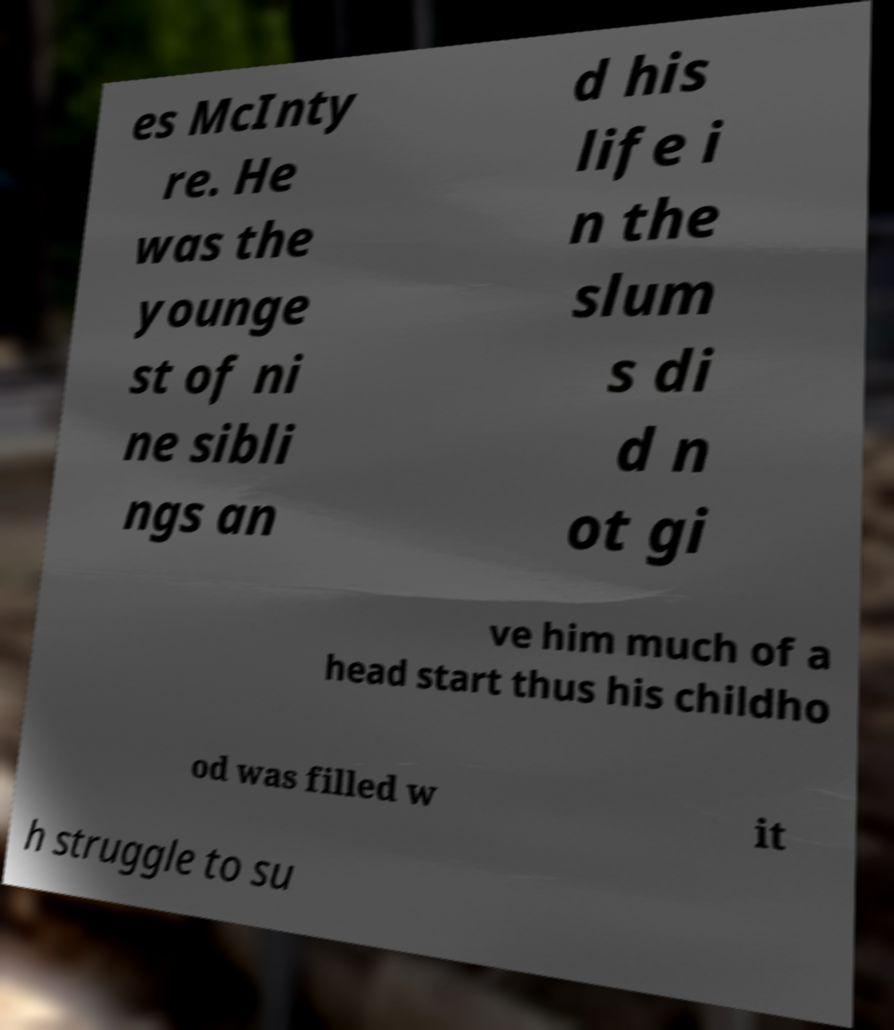There's text embedded in this image that I need extracted. Can you transcribe it verbatim? es McInty re. He was the younge st of ni ne sibli ngs an d his life i n the slum s di d n ot gi ve him much of a head start thus his childho od was filled w it h struggle to su 